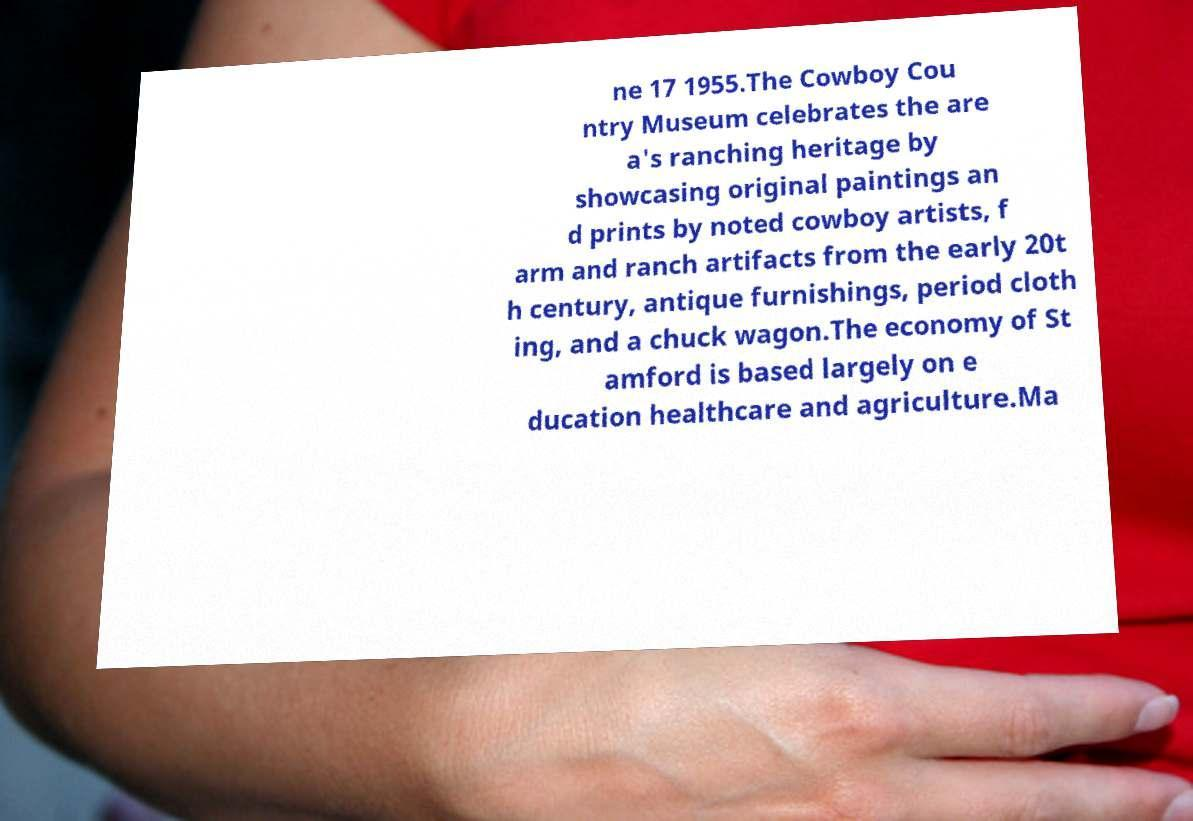Could you extract and type out the text from this image? ne 17 1955.The Cowboy Cou ntry Museum celebrates the are a's ranching heritage by showcasing original paintings an d prints by noted cowboy artists, f arm and ranch artifacts from the early 20t h century, antique furnishings, period cloth ing, and a chuck wagon.The economy of St amford is based largely on e ducation healthcare and agriculture.Ma 